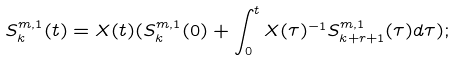<formula> <loc_0><loc_0><loc_500><loc_500>S _ { k } ^ { m , 1 } ( t ) = X ( t ) ( S _ { k } ^ { m , 1 } ( 0 ) + \int _ { 0 } ^ { t } X ( \tau ) ^ { - 1 } S _ { k + r + 1 } ^ { m , 1 } ( \tau ) d \tau ) ;</formula> 